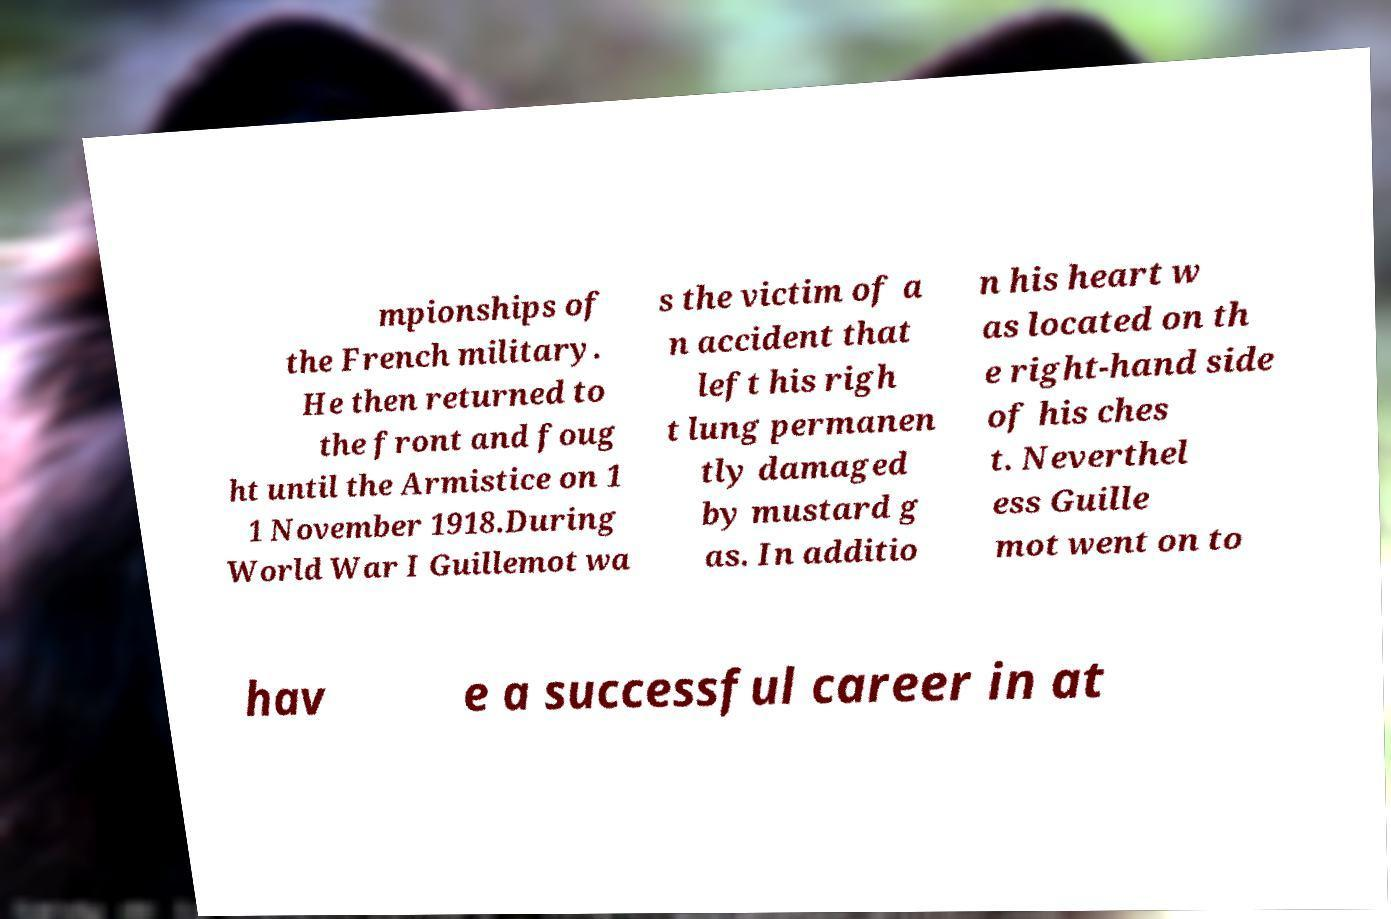I need the written content from this picture converted into text. Can you do that? mpionships of the French military. He then returned to the front and foug ht until the Armistice on 1 1 November 1918.During World War I Guillemot wa s the victim of a n accident that left his righ t lung permanen tly damaged by mustard g as. In additio n his heart w as located on th e right-hand side of his ches t. Neverthel ess Guille mot went on to hav e a successful career in at 